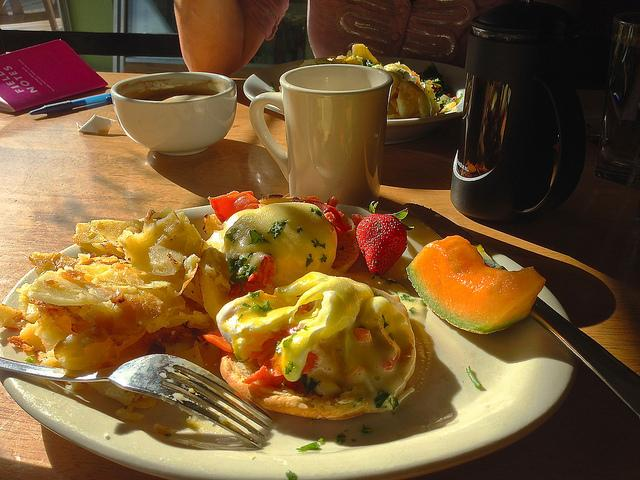What is the yellow sauce's name in the culinary world? Please explain your reasoning. hollandaise. It is used a lot on eggs. 